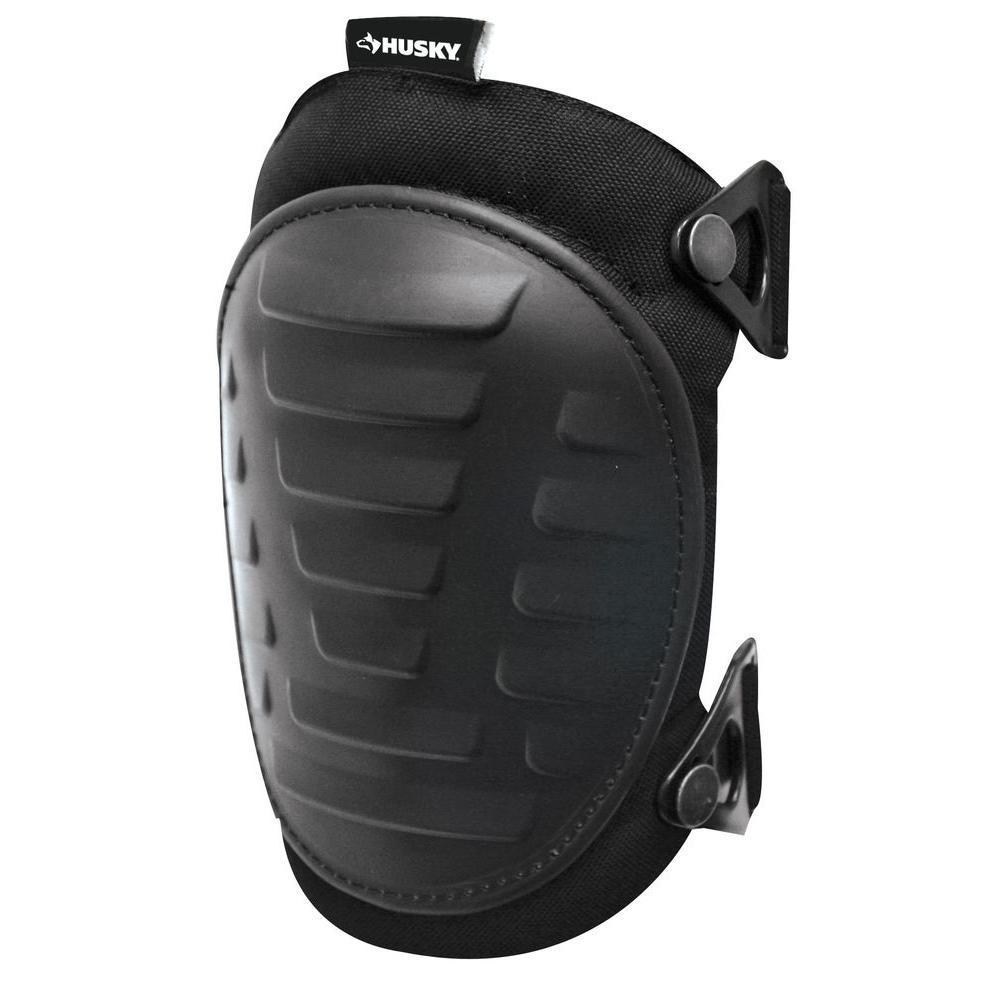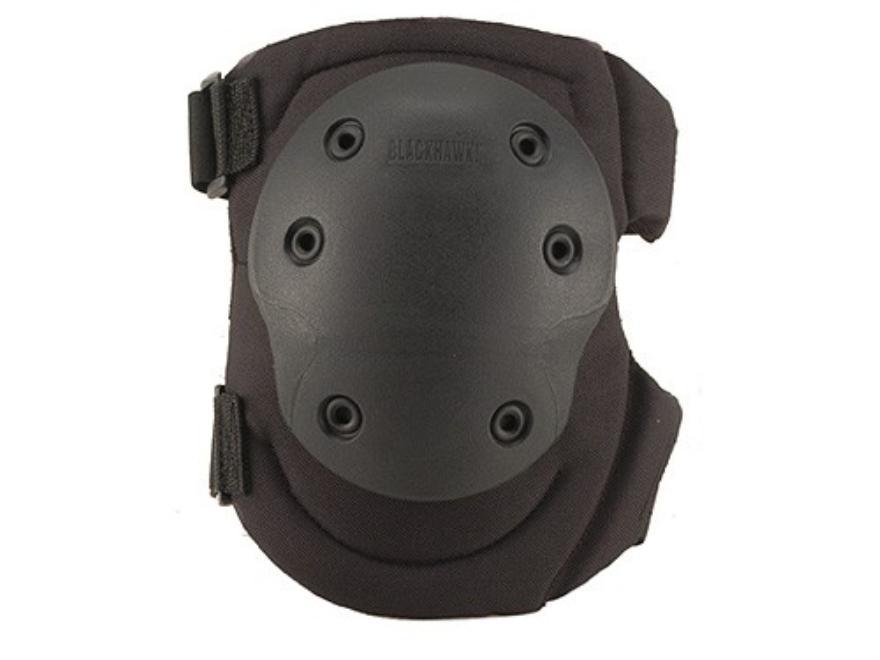The first image is the image on the left, the second image is the image on the right. Evaluate the accuracy of this statement regarding the images: "Two sets of kneepads are shown as they fit on legs over jeans.". Is it true? Answer yes or no. No. The first image is the image on the left, the second image is the image on the right. Given the left and right images, does the statement "Both images show knee pads worn over denim jeans." hold true? Answer yes or no. No. 